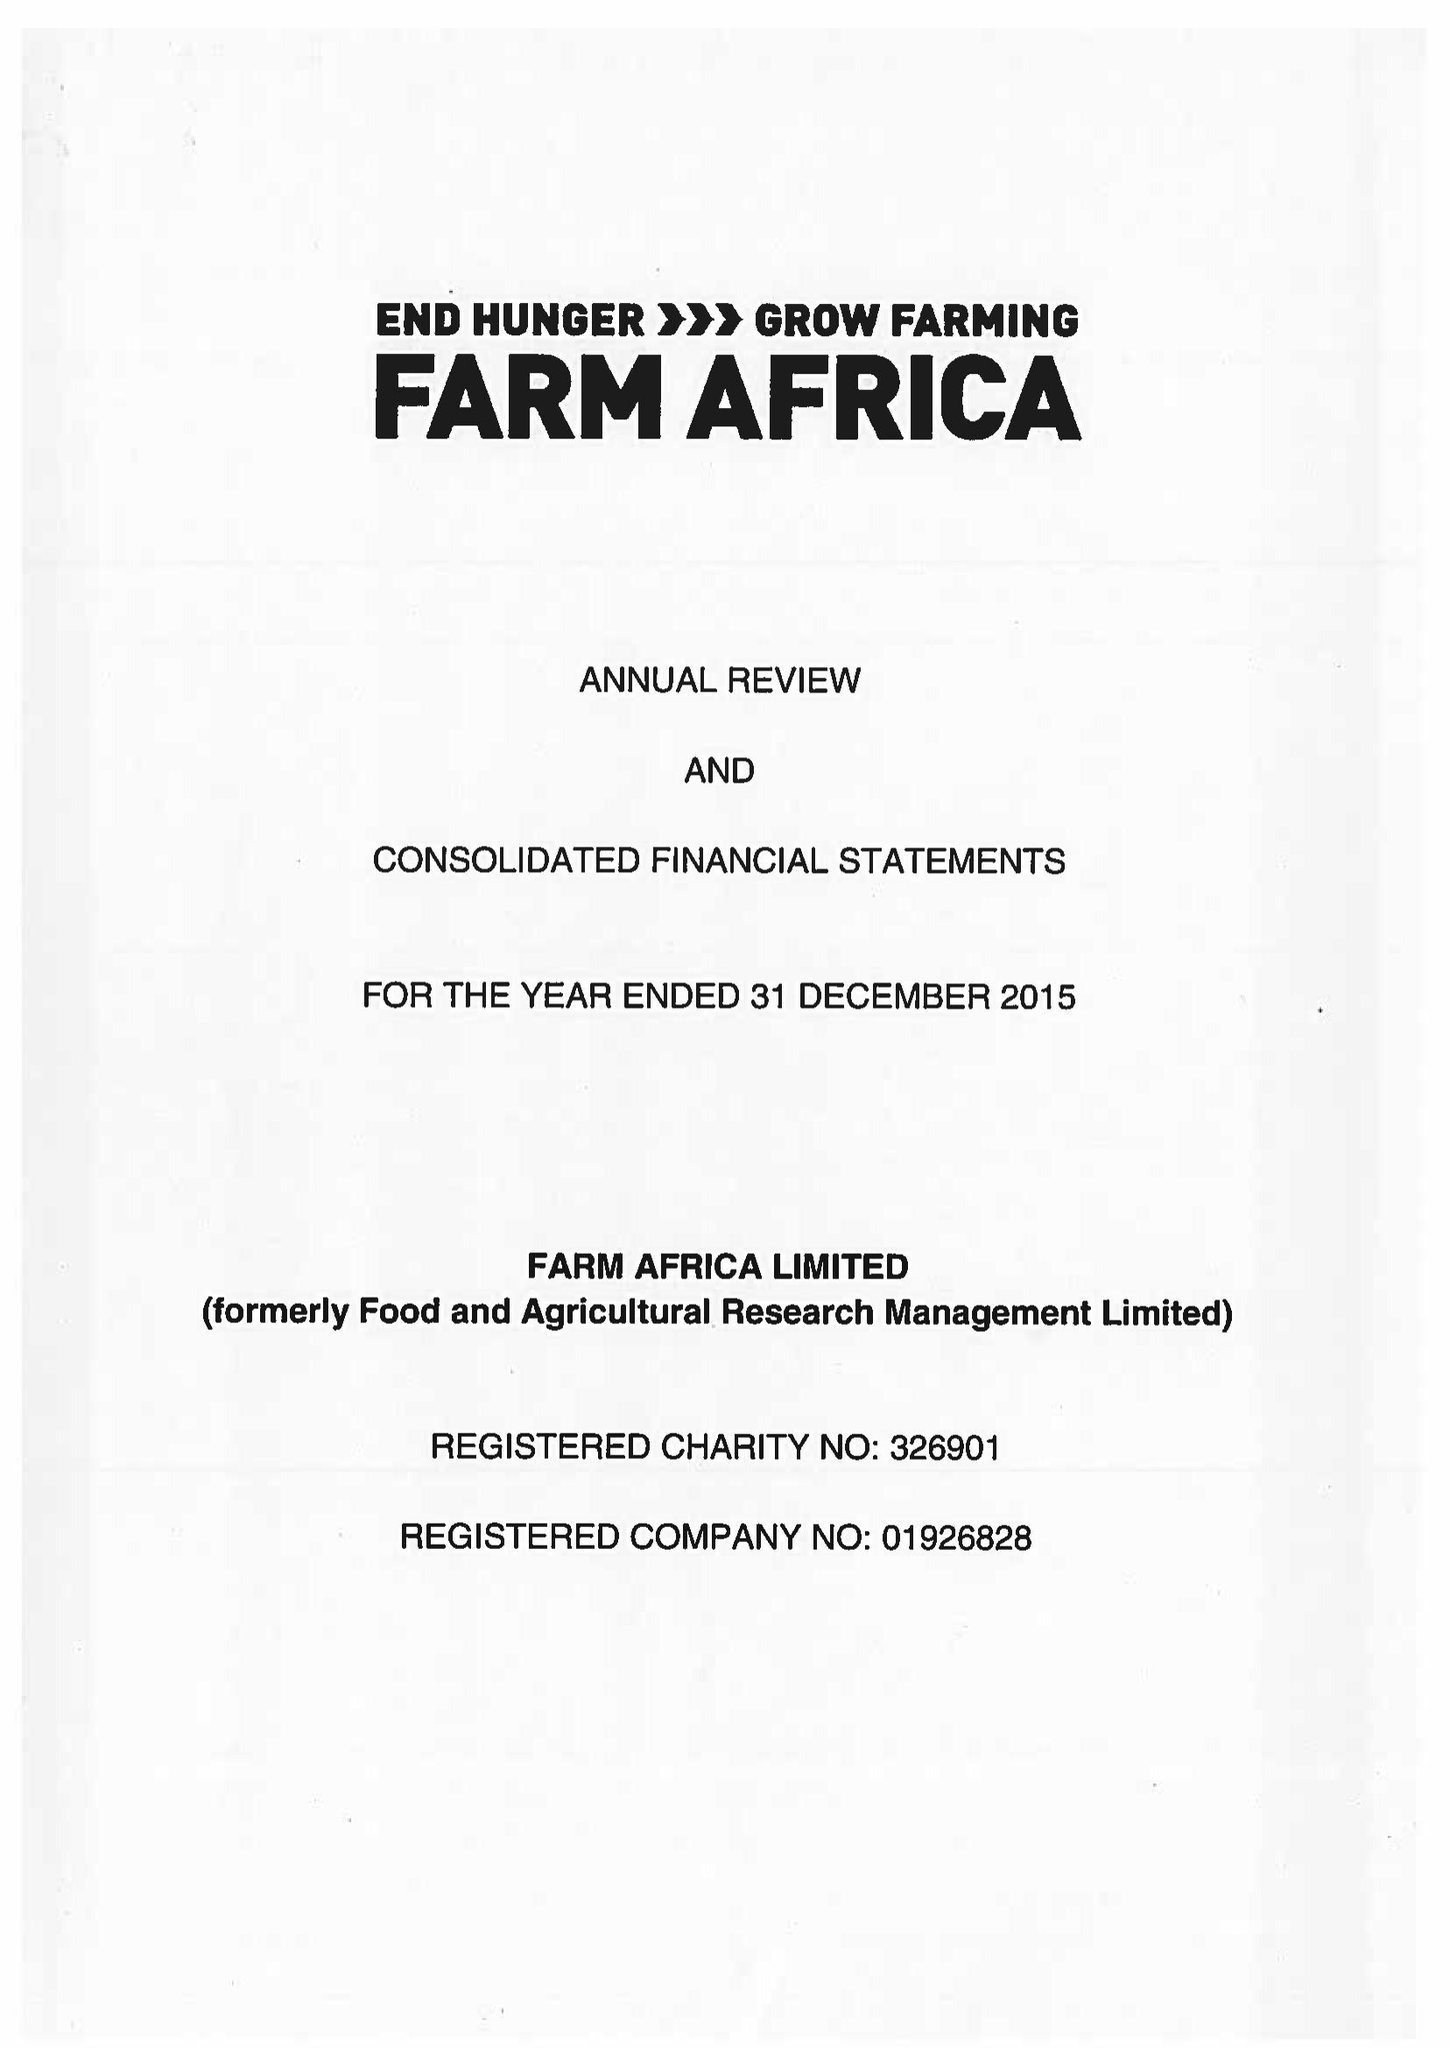What is the value for the address__postcode?
Answer the question using a single word or phrase. EC2Y 5DN 